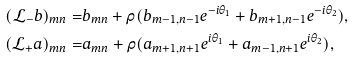<formula> <loc_0><loc_0><loc_500><loc_500>( \mathcal { L } _ { - } b ) _ { m n } = & b _ { m n } + \rho ( b _ { m - 1 , n - 1 } e ^ { - i \theta _ { 1 } } + b _ { m + 1 , n - 1 } e ^ { - i \theta _ { 2 } } ) , \\ ( \mathcal { L } _ { + } a ) _ { m n } = & a _ { m n } + \rho ( a _ { m + 1 , n + 1 } e ^ { i \theta _ { 1 } } + a _ { m - 1 , n + 1 } e ^ { i \theta _ { 2 } } ) ,</formula> 